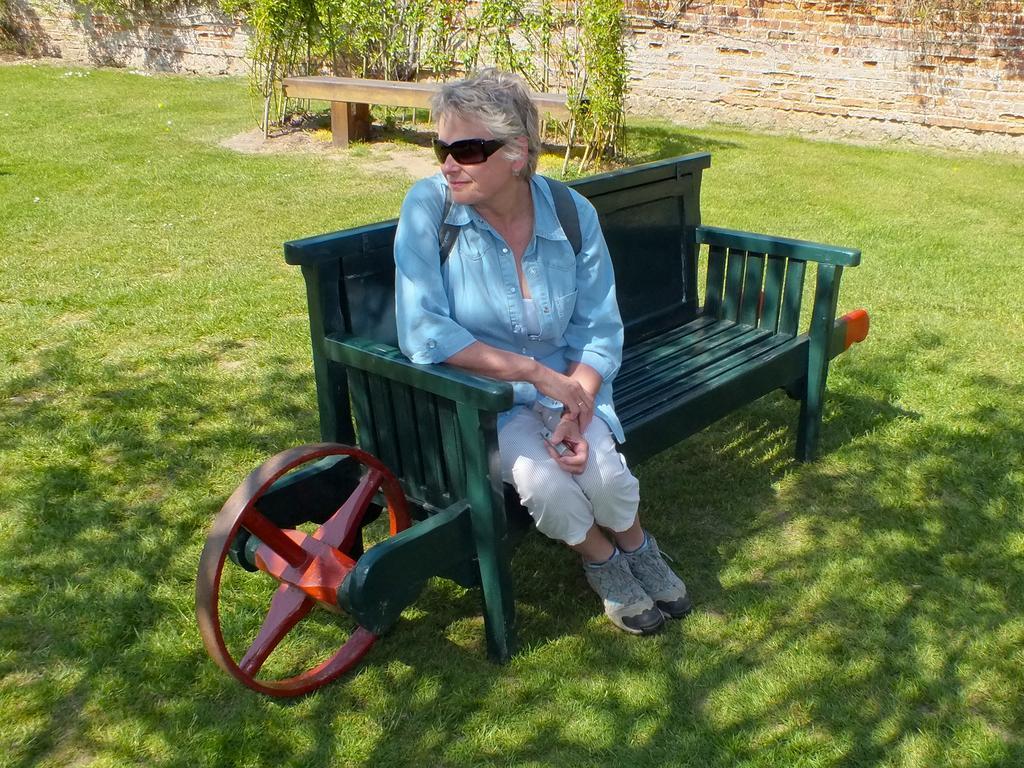Please provide a concise description of this image. In this image we can see an old woman is sitting on the bench. In the background we can see plants and wall. 